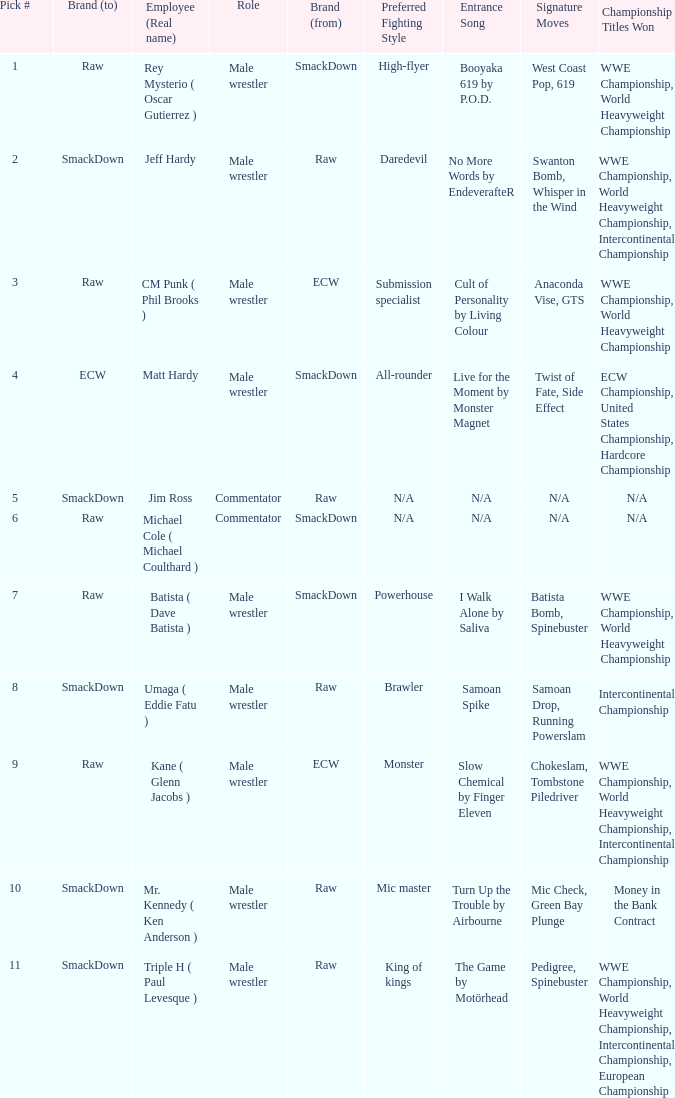What is the real name of the Pick # that is greater than 9? Mr. Kennedy ( Ken Anderson ), Triple H ( Paul Levesque ). 